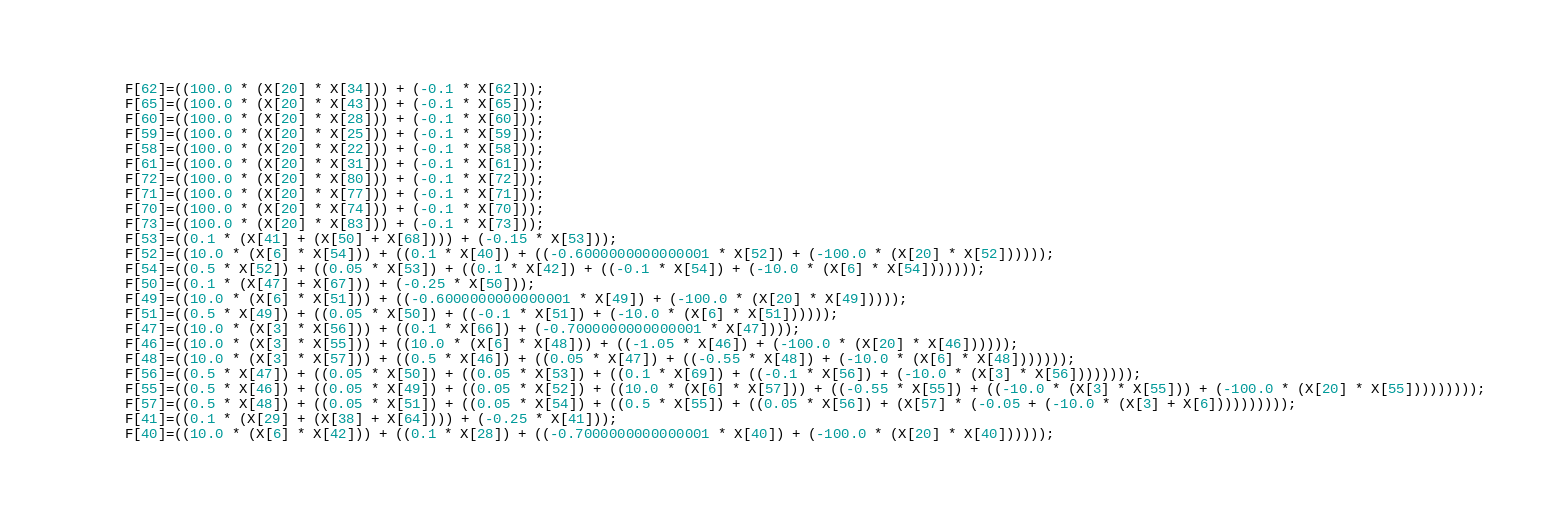<code> <loc_0><loc_0><loc_500><loc_500><_Cuda_>    F[62]=((100.0 * (X[20] * X[34])) + (-0.1 * X[62]));
    F[65]=((100.0 * (X[20] * X[43])) + (-0.1 * X[65]));
    F[60]=((100.0 * (X[20] * X[28])) + (-0.1 * X[60]));
    F[59]=((100.0 * (X[20] * X[25])) + (-0.1 * X[59]));
    F[58]=((100.0 * (X[20] * X[22])) + (-0.1 * X[58]));
    F[61]=((100.0 * (X[20] * X[31])) + (-0.1 * X[61]));
    F[72]=((100.0 * (X[20] * X[80])) + (-0.1 * X[72]));
    F[71]=((100.0 * (X[20] * X[77])) + (-0.1 * X[71]));
    F[70]=((100.0 * (X[20] * X[74])) + (-0.1 * X[70]));
    F[73]=((100.0 * (X[20] * X[83])) + (-0.1 * X[73]));
    F[53]=((0.1 * (X[41] + (X[50] + X[68]))) + (-0.15 * X[53]));
    F[52]=((10.0 * (X[6] * X[54])) + ((0.1 * X[40]) + ((-0.6000000000000001 * X[52]) + (-100.0 * (X[20] * X[52])))));
    F[54]=((0.5 * X[52]) + ((0.05 * X[53]) + ((0.1 * X[42]) + ((-0.1 * X[54]) + (-10.0 * (X[6] * X[54]))))));
    F[50]=((0.1 * (X[47] + X[67])) + (-0.25 * X[50]));
    F[49]=((10.0 * (X[6] * X[51])) + ((-0.6000000000000001 * X[49]) + (-100.0 * (X[20] * X[49]))));
    F[51]=((0.5 * X[49]) + ((0.05 * X[50]) + ((-0.1 * X[51]) + (-10.0 * (X[6] * X[51])))));
    F[47]=((10.0 * (X[3] * X[56])) + ((0.1 * X[66]) + (-0.7000000000000001 * X[47])));
    F[46]=((10.0 * (X[3] * X[55])) + ((10.0 * (X[6] * X[48])) + ((-1.05 * X[46]) + (-100.0 * (X[20] * X[46])))));
    F[48]=((10.0 * (X[3] * X[57])) + ((0.5 * X[46]) + ((0.05 * X[47]) + ((-0.55 * X[48]) + (-10.0 * (X[6] * X[48]))))));
    F[56]=((0.5 * X[47]) + ((0.05 * X[50]) + ((0.05 * X[53]) + ((0.1 * X[69]) + ((-0.1 * X[56]) + (-10.0 * (X[3] * X[56])))))));
    F[55]=((0.5 * X[46]) + ((0.05 * X[49]) + ((0.05 * X[52]) + ((10.0 * (X[6] * X[57])) + ((-0.55 * X[55]) + ((-10.0 * (X[3] * X[55])) + (-100.0 * (X[20] * X[55]))))))));
    F[57]=((0.5 * X[48]) + ((0.05 * X[51]) + ((0.05 * X[54]) + ((0.5 * X[55]) + ((0.05 * X[56]) + (X[57] * (-0.05 + (-10.0 * (X[3] + X[6])))))))));
    F[41]=((0.1 * (X[29] + (X[38] + X[64]))) + (-0.25 * X[41]));
    F[40]=((10.0 * (X[6] * X[42])) + ((0.1 * X[28]) + ((-0.7000000000000001 * X[40]) + (-100.0 * (X[20] * X[40])))));</code> 